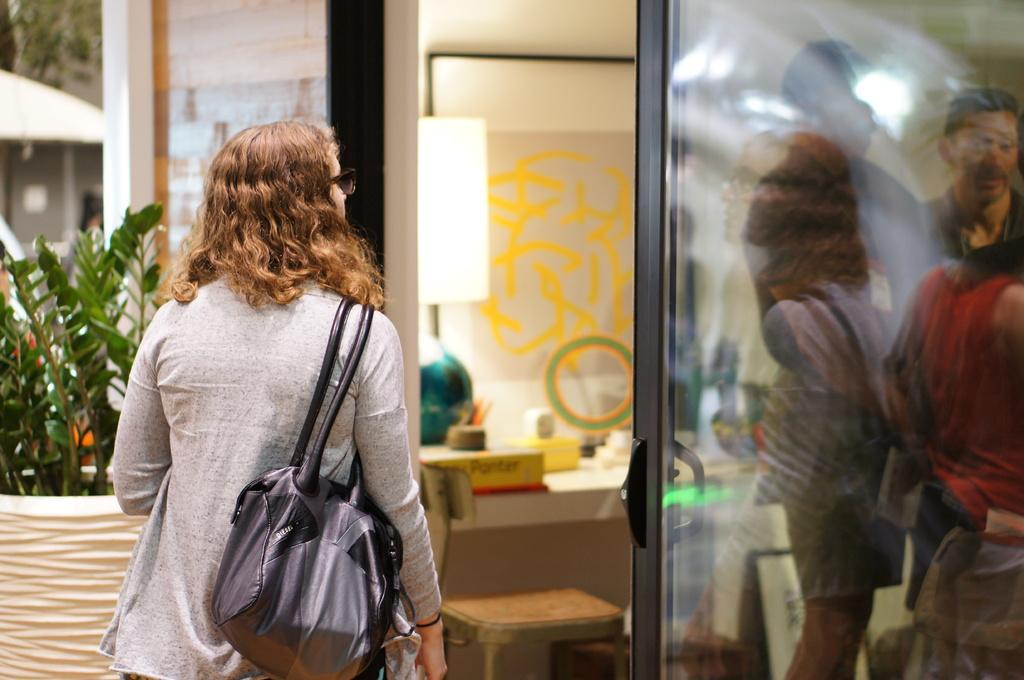What is the primary subject in the image? There is a person standing in the image. Can you describe what the person is wearing? The person is wearing a bag. What type of furniture can be seen in the image? There is a chair in the image. What is on the table in the image? There are objects on a table in the image. What is the background of the image composed of? There is a wall in the image. Are there any plants visible in the image? Yes, there is a plant in the image. What architectural feature is present in the image? There is a glass door in the image. Can you describe what is visible through the glass door? There are persons visible through the glass door. What type of boot is being offered to the person in the image? There is no boot being offered in the image; the person is wearing a bag. 